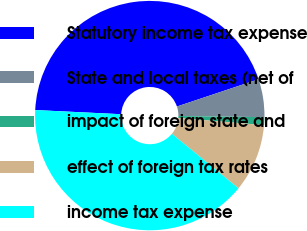<chart> <loc_0><loc_0><loc_500><loc_500><pie_chart><fcel>Statutory income tax expense<fcel>State and local taxes (net of<fcel>impact of foreign state and<fcel>effect of foreign tax rates<fcel>income tax expense<nl><fcel>44.09%<fcel>5.35%<fcel>1.11%<fcel>9.6%<fcel>39.84%<nl></chart> 